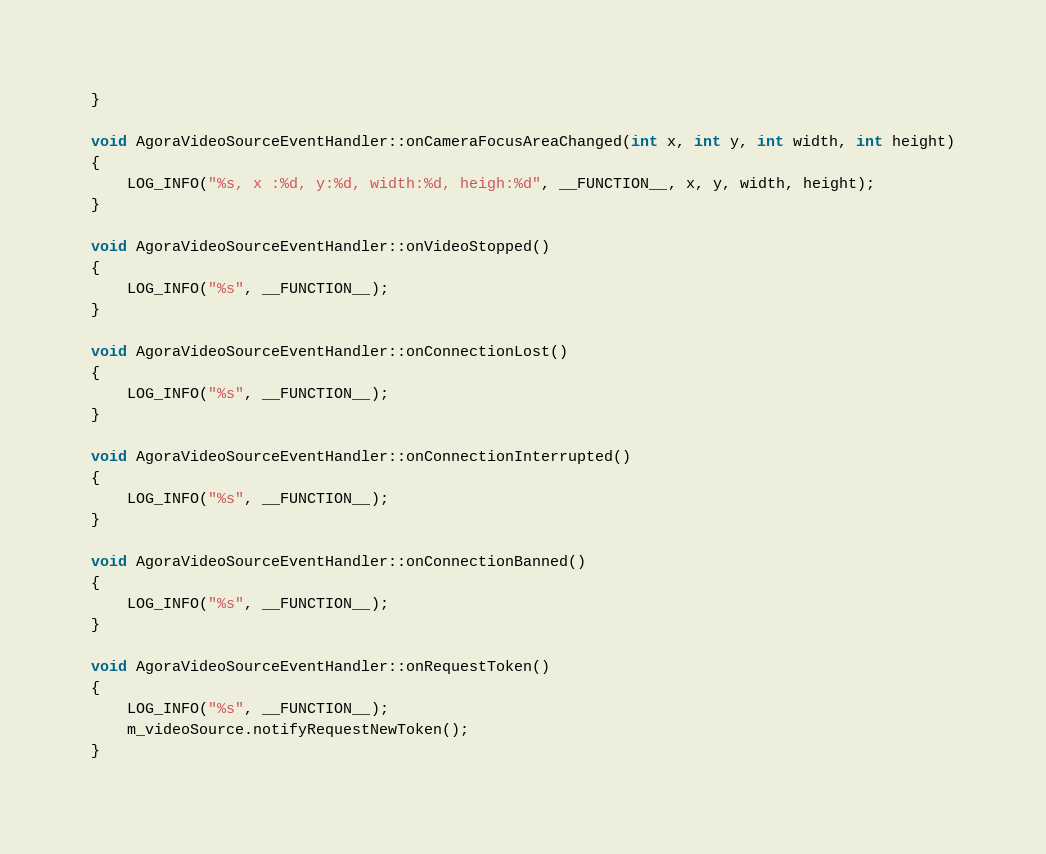Convert code to text. <code><loc_0><loc_0><loc_500><loc_500><_C++_>}

void AgoraVideoSourceEventHandler::onCameraFocusAreaChanged(int x, int y, int width, int height)
{
    LOG_INFO("%s, x :%d, y:%d, width:%d, heigh:%d", __FUNCTION__, x, y, width, height);
}

void AgoraVideoSourceEventHandler::onVideoStopped()
{
    LOG_INFO("%s", __FUNCTION__);
}

void AgoraVideoSourceEventHandler::onConnectionLost()
{
    LOG_INFO("%s", __FUNCTION__);
}

void AgoraVideoSourceEventHandler::onConnectionInterrupted()
{
    LOG_INFO("%s", __FUNCTION__);
}

void AgoraVideoSourceEventHandler::onConnectionBanned()
{
    LOG_INFO("%s", __FUNCTION__);
}

void AgoraVideoSourceEventHandler::onRequestToken()
{
    LOG_INFO("%s", __FUNCTION__);
    m_videoSource.notifyRequestNewToken();
}
</code> 